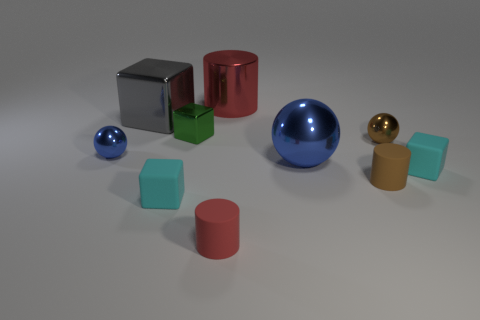Subtract 1 cubes. How many cubes are left? 3 Subtract all cylinders. How many objects are left? 7 Add 8 tiny yellow objects. How many tiny yellow objects exist? 8 Subtract 0 gray balls. How many objects are left? 10 Subtract all cyan cubes. Subtract all big blocks. How many objects are left? 7 Add 2 large metallic balls. How many large metallic balls are left? 3 